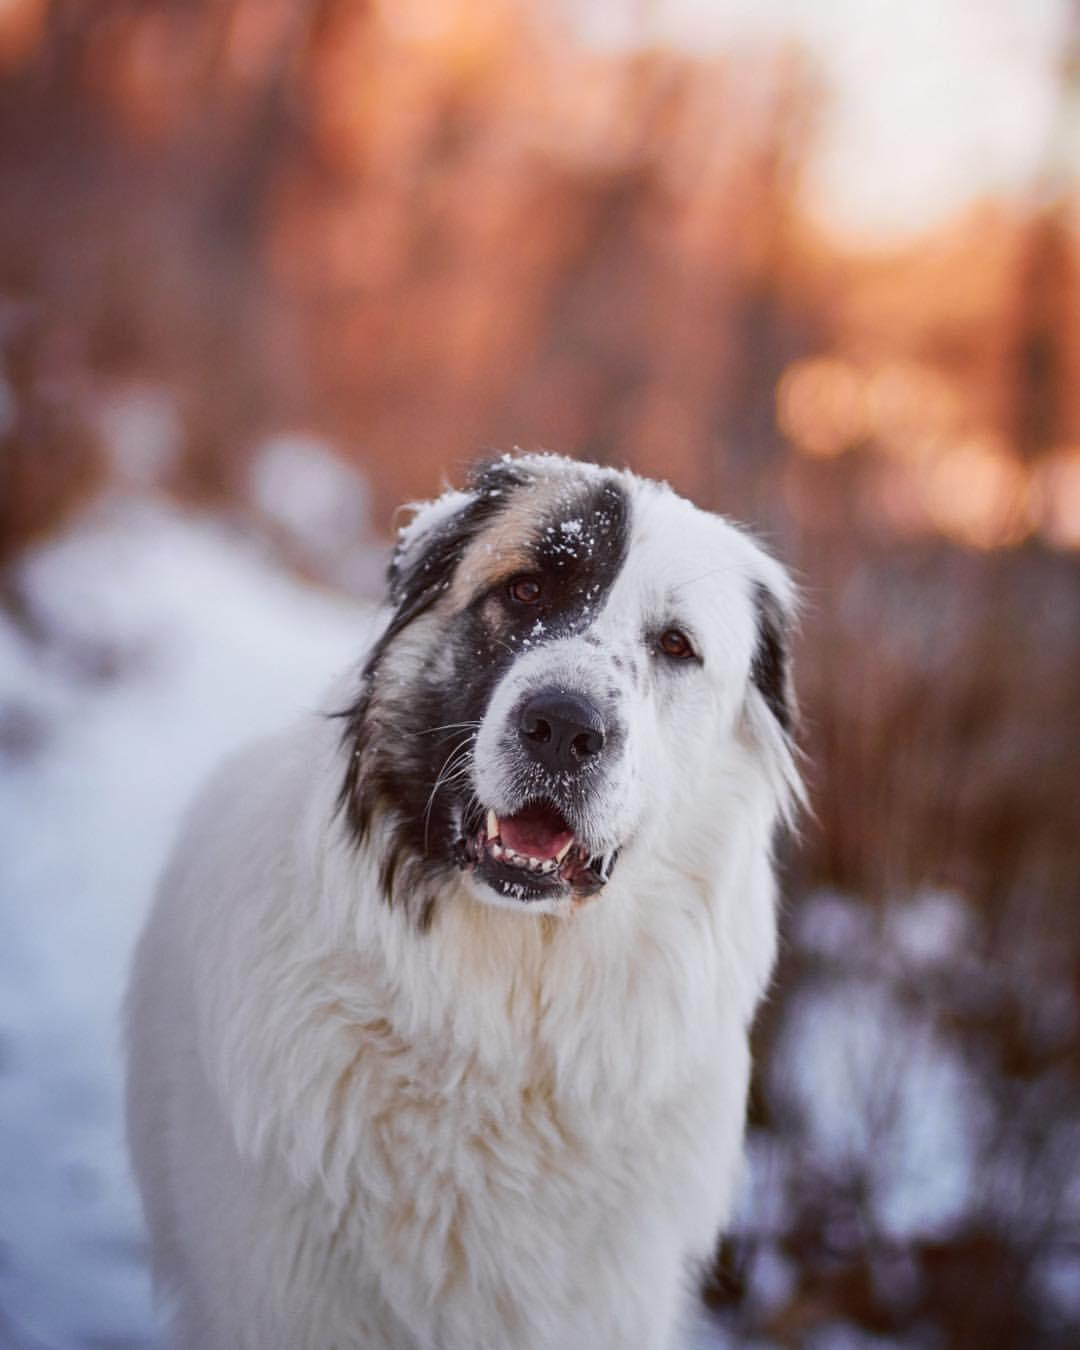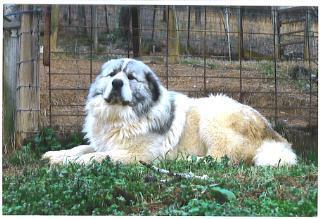The first image is the image on the left, the second image is the image on the right. Given the left and right images, does the statement "Right image shows exactly one white dog, which is standing on all fours on grass." hold true? Answer yes or no. No. The first image is the image on the left, the second image is the image on the right. Examine the images to the left and right. Is the description "The dog in the image on the right is on green grass." accurate? Answer yes or no. Yes. 